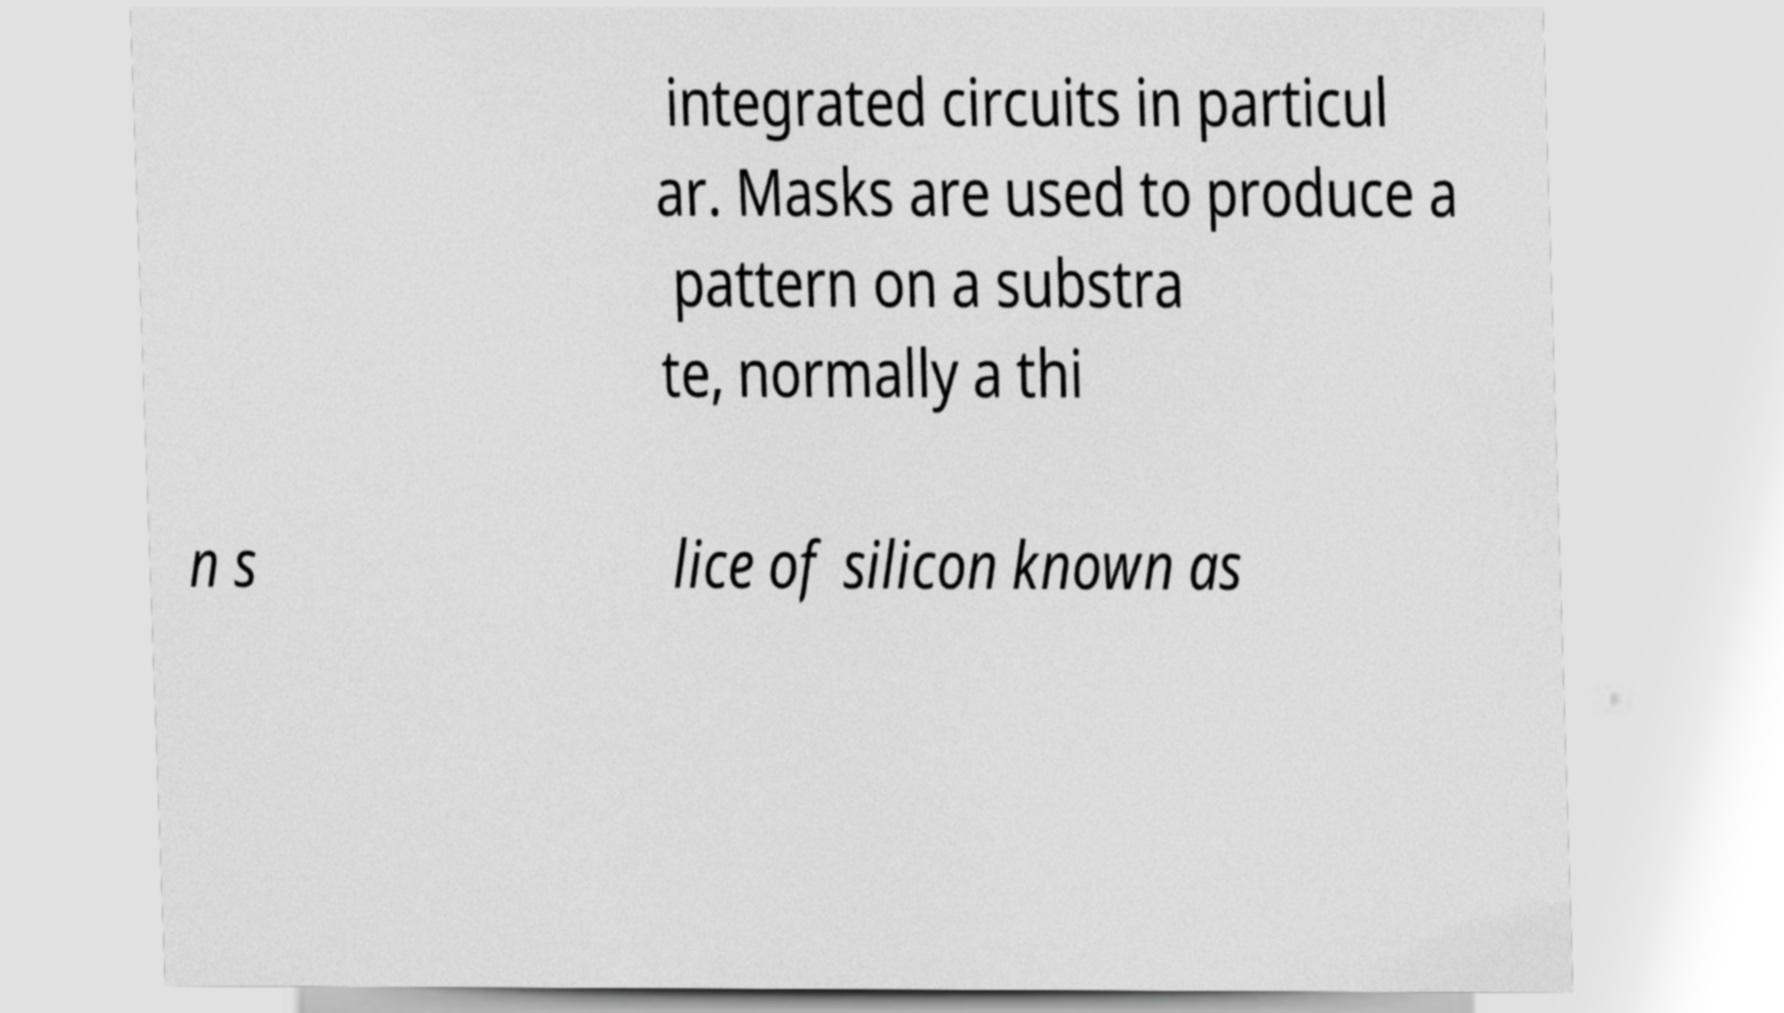Could you assist in decoding the text presented in this image and type it out clearly? integrated circuits in particul ar. Masks are used to produce a pattern on a substra te, normally a thi n s lice of silicon known as 